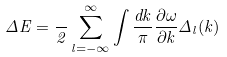Convert formula to latex. <formula><loc_0><loc_0><loc_500><loc_500>\Delta E = \frac { } { 2 } \sum _ { l = - \infty } ^ { \infty } \int \frac { d k } { \pi } \frac { \partial \omega } { \partial k } \Delta _ { l } ( k )</formula> 